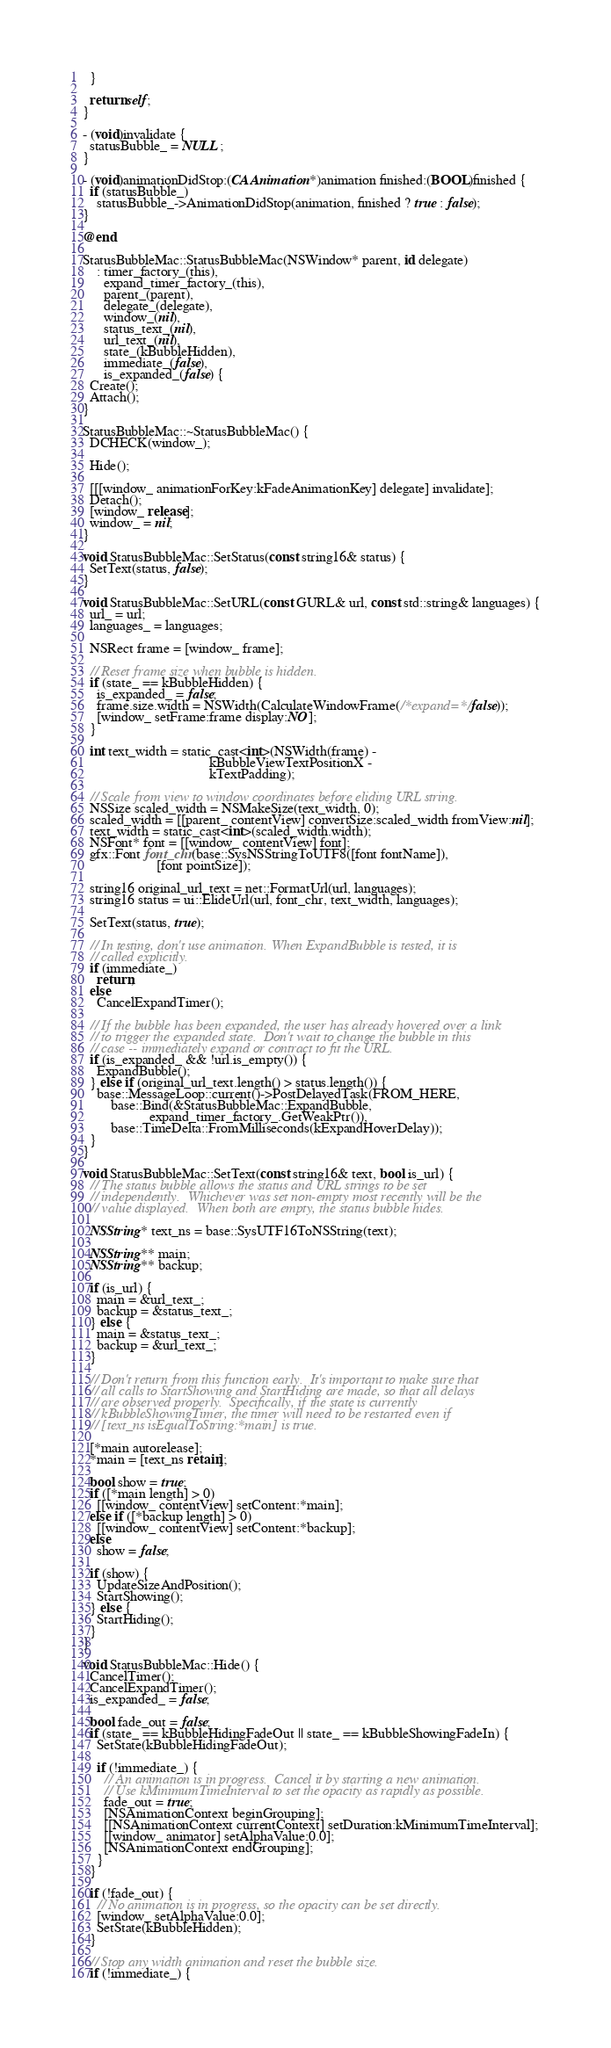<code> <loc_0><loc_0><loc_500><loc_500><_ObjectiveC_>  }

  return self;
}

- (void)invalidate {
  statusBubble_ = NULL;
}

- (void)animationDidStop:(CAAnimation*)animation finished:(BOOL)finished {
  if (statusBubble_)
    statusBubble_->AnimationDidStop(animation, finished ? true : false);
}

@end

StatusBubbleMac::StatusBubbleMac(NSWindow* parent, id delegate)
    : timer_factory_(this),
      expand_timer_factory_(this),
      parent_(parent),
      delegate_(delegate),
      window_(nil),
      status_text_(nil),
      url_text_(nil),
      state_(kBubbleHidden),
      immediate_(false),
      is_expanded_(false) {
  Create();
  Attach();
}

StatusBubbleMac::~StatusBubbleMac() {
  DCHECK(window_);

  Hide();

  [[[window_ animationForKey:kFadeAnimationKey] delegate] invalidate];
  Detach();
  [window_ release];
  window_ = nil;
}

void StatusBubbleMac::SetStatus(const string16& status) {
  SetText(status, false);
}

void StatusBubbleMac::SetURL(const GURL& url, const std::string& languages) {
  url_ = url;
  languages_ = languages;

  NSRect frame = [window_ frame];

  // Reset frame size when bubble is hidden.
  if (state_ == kBubbleHidden) {
    is_expanded_ = false;
    frame.size.width = NSWidth(CalculateWindowFrame(/*expand=*/false));
    [window_ setFrame:frame display:NO];
  }

  int text_width = static_cast<int>(NSWidth(frame) -
                                    kBubbleViewTextPositionX -
                                    kTextPadding);

  // Scale from view to window coordinates before eliding URL string.
  NSSize scaled_width = NSMakeSize(text_width, 0);
  scaled_width = [[parent_ contentView] convertSize:scaled_width fromView:nil];
  text_width = static_cast<int>(scaled_width.width);
  NSFont* font = [[window_ contentView] font];
  gfx::Font font_chr(base::SysNSStringToUTF8([font fontName]),
                     [font pointSize]);

  string16 original_url_text = net::FormatUrl(url, languages);
  string16 status = ui::ElideUrl(url, font_chr, text_width, languages);

  SetText(status, true);

  // In testing, don't use animation. When ExpandBubble is tested, it is
  // called explicitly.
  if (immediate_)
    return;
  else
    CancelExpandTimer();

  // If the bubble has been expanded, the user has already hovered over a link
  // to trigger the expanded state.  Don't wait to change the bubble in this
  // case -- immediately expand or contract to fit the URL.
  if (is_expanded_ && !url.is_empty()) {
    ExpandBubble();
  } else if (original_url_text.length() > status.length()) {
    base::MessageLoop::current()->PostDelayedTask(FROM_HERE,
        base::Bind(&StatusBubbleMac::ExpandBubble,
                   expand_timer_factory_.GetWeakPtr()),
        base::TimeDelta::FromMilliseconds(kExpandHoverDelay));
  }
}

void StatusBubbleMac::SetText(const string16& text, bool is_url) {
  // The status bubble allows the status and URL strings to be set
  // independently.  Whichever was set non-empty most recently will be the
  // value displayed.  When both are empty, the status bubble hides.

  NSString* text_ns = base::SysUTF16ToNSString(text);

  NSString** main;
  NSString** backup;

  if (is_url) {
    main = &url_text_;
    backup = &status_text_;
  } else {
    main = &status_text_;
    backup = &url_text_;
  }

  // Don't return from this function early.  It's important to make sure that
  // all calls to StartShowing and StartHiding are made, so that all delays
  // are observed properly.  Specifically, if the state is currently
  // kBubbleShowingTimer, the timer will need to be restarted even if
  // [text_ns isEqualToString:*main] is true.

  [*main autorelease];
  *main = [text_ns retain];

  bool show = true;
  if ([*main length] > 0)
    [[window_ contentView] setContent:*main];
  else if ([*backup length] > 0)
    [[window_ contentView] setContent:*backup];
  else
    show = false;

  if (show) {
    UpdateSizeAndPosition();
    StartShowing();
  } else {
    StartHiding();
  }
}

void StatusBubbleMac::Hide() {
  CancelTimer();
  CancelExpandTimer();
  is_expanded_ = false;

  bool fade_out = false;
  if (state_ == kBubbleHidingFadeOut || state_ == kBubbleShowingFadeIn) {
    SetState(kBubbleHidingFadeOut);

    if (!immediate_) {
      // An animation is in progress.  Cancel it by starting a new animation.
      // Use kMinimumTimeInterval to set the opacity as rapidly as possible.
      fade_out = true;
      [NSAnimationContext beginGrouping];
      [[NSAnimationContext currentContext] setDuration:kMinimumTimeInterval];
      [[window_ animator] setAlphaValue:0.0];
      [NSAnimationContext endGrouping];
    }
  }

  if (!fade_out) {
    // No animation is in progress, so the opacity can be set directly.
    [window_ setAlphaValue:0.0];
    SetState(kBubbleHidden);
  }

  // Stop any width animation and reset the bubble size.
  if (!immediate_) {</code> 